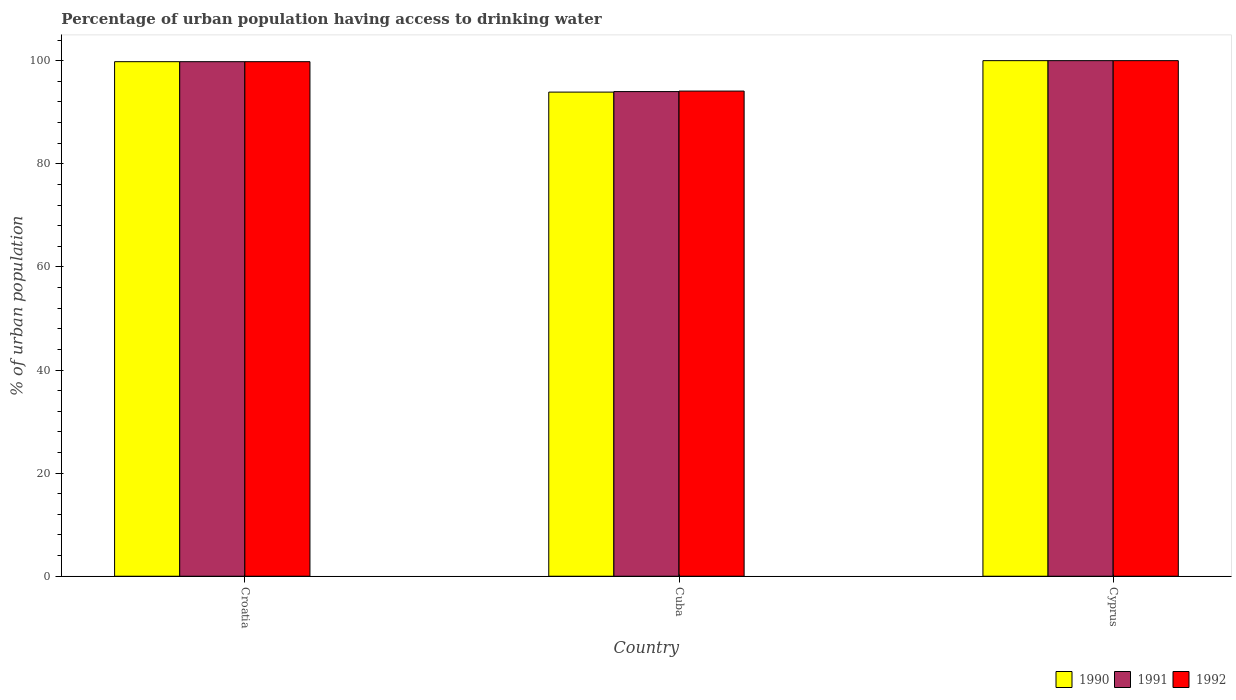How many different coloured bars are there?
Provide a short and direct response. 3. How many groups of bars are there?
Your answer should be compact. 3. Are the number of bars per tick equal to the number of legend labels?
Give a very brief answer. Yes. What is the label of the 1st group of bars from the left?
Keep it short and to the point. Croatia. What is the percentage of urban population having access to drinking water in 1991 in Cuba?
Offer a very short reply. 94. Across all countries, what is the minimum percentage of urban population having access to drinking water in 1992?
Give a very brief answer. 94.1. In which country was the percentage of urban population having access to drinking water in 1990 maximum?
Offer a very short reply. Cyprus. In which country was the percentage of urban population having access to drinking water in 1992 minimum?
Your answer should be compact. Cuba. What is the total percentage of urban population having access to drinking water in 1991 in the graph?
Your answer should be compact. 293.8. What is the difference between the percentage of urban population having access to drinking water in 1990 in Cuba and that in Cyprus?
Keep it short and to the point. -6.1. What is the difference between the percentage of urban population having access to drinking water in 1992 in Croatia and the percentage of urban population having access to drinking water in 1991 in Cuba?
Your response must be concise. 5.8. What is the average percentage of urban population having access to drinking water in 1990 per country?
Offer a terse response. 97.9. In how many countries, is the percentage of urban population having access to drinking water in 1991 greater than 88 %?
Your answer should be compact. 3. What is the ratio of the percentage of urban population having access to drinking water in 1992 in Cuba to that in Cyprus?
Your answer should be compact. 0.94. What is the difference between the highest and the second highest percentage of urban population having access to drinking water in 1991?
Make the answer very short. -0.2. What is the difference between the highest and the lowest percentage of urban population having access to drinking water in 1990?
Your answer should be compact. 6.1. In how many countries, is the percentage of urban population having access to drinking water in 1992 greater than the average percentage of urban population having access to drinking water in 1992 taken over all countries?
Your answer should be very brief. 2. Is the sum of the percentage of urban population having access to drinking water in 1992 in Cuba and Cyprus greater than the maximum percentage of urban population having access to drinking water in 1990 across all countries?
Keep it short and to the point. Yes. What does the 1st bar from the right in Cuba represents?
Your answer should be compact. 1992. Is it the case that in every country, the sum of the percentage of urban population having access to drinking water in 1990 and percentage of urban population having access to drinking water in 1992 is greater than the percentage of urban population having access to drinking water in 1991?
Provide a succinct answer. Yes. How many bars are there?
Your response must be concise. 9. How many countries are there in the graph?
Give a very brief answer. 3. Does the graph contain grids?
Your answer should be very brief. No. What is the title of the graph?
Offer a terse response. Percentage of urban population having access to drinking water. What is the label or title of the Y-axis?
Offer a terse response. % of urban population. What is the % of urban population in 1990 in Croatia?
Give a very brief answer. 99.8. What is the % of urban population in 1991 in Croatia?
Make the answer very short. 99.8. What is the % of urban population in 1992 in Croatia?
Offer a terse response. 99.8. What is the % of urban population in 1990 in Cuba?
Offer a terse response. 93.9. What is the % of urban population of 1991 in Cuba?
Your answer should be compact. 94. What is the % of urban population of 1992 in Cuba?
Provide a succinct answer. 94.1. What is the % of urban population in 1990 in Cyprus?
Keep it short and to the point. 100. What is the % of urban population in 1991 in Cyprus?
Provide a short and direct response. 100. What is the % of urban population in 1992 in Cyprus?
Your answer should be very brief. 100. Across all countries, what is the maximum % of urban population of 1991?
Provide a succinct answer. 100. Across all countries, what is the maximum % of urban population of 1992?
Provide a succinct answer. 100. Across all countries, what is the minimum % of urban population in 1990?
Keep it short and to the point. 93.9. Across all countries, what is the minimum % of urban population in 1991?
Provide a succinct answer. 94. Across all countries, what is the minimum % of urban population in 1992?
Give a very brief answer. 94.1. What is the total % of urban population of 1990 in the graph?
Offer a very short reply. 293.7. What is the total % of urban population of 1991 in the graph?
Your answer should be very brief. 293.8. What is the total % of urban population of 1992 in the graph?
Offer a very short reply. 293.9. What is the difference between the % of urban population of 1990 in Croatia and that in Cuba?
Provide a succinct answer. 5.9. What is the difference between the % of urban population in 1991 in Croatia and that in Cuba?
Provide a succinct answer. 5.8. What is the difference between the % of urban population of 1992 in Croatia and that in Cuba?
Make the answer very short. 5.7. What is the difference between the % of urban population in 1991 in Croatia and that in Cyprus?
Your response must be concise. -0.2. What is the difference between the % of urban population of 1990 in Croatia and the % of urban population of 1992 in Cyprus?
Provide a short and direct response. -0.2. What is the difference between the % of urban population in 1990 in Cuba and the % of urban population in 1992 in Cyprus?
Offer a terse response. -6.1. What is the average % of urban population in 1990 per country?
Your answer should be very brief. 97.9. What is the average % of urban population of 1991 per country?
Ensure brevity in your answer.  97.93. What is the average % of urban population of 1992 per country?
Give a very brief answer. 97.97. What is the difference between the % of urban population in 1990 and % of urban population in 1992 in Croatia?
Offer a very short reply. 0. What is the difference between the % of urban population of 1991 and % of urban population of 1992 in Croatia?
Offer a very short reply. 0. What is the difference between the % of urban population of 1990 and % of urban population of 1991 in Cuba?
Give a very brief answer. -0.1. What is the difference between the % of urban population in 1990 and % of urban population in 1992 in Cyprus?
Ensure brevity in your answer.  0. What is the ratio of the % of urban population in 1990 in Croatia to that in Cuba?
Offer a very short reply. 1.06. What is the ratio of the % of urban population of 1991 in Croatia to that in Cuba?
Provide a short and direct response. 1.06. What is the ratio of the % of urban population of 1992 in Croatia to that in Cuba?
Provide a short and direct response. 1.06. What is the ratio of the % of urban population of 1990 in Croatia to that in Cyprus?
Ensure brevity in your answer.  1. What is the ratio of the % of urban population of 1991 in Croatia to that in Cyprus?
Provide a succinct answer. 1. What is the ratio of the % of urban population in 1990 in Cuba to that in Cyprus?
Ensure brevity in your answer.  0.94. What is the ratio of the % of urban population in 1992 in Cuba to that in Cyprus?
Ensure brevity in your answer.  0.94. What is the difference between the highest and the second highest % of urban population of 1992?
Provide a succinct answer. 0.2. What is the difference between the highest and the lowest % of urban population of 1990?
Give a very brief answer. 6.1. What is the difference between the highest and the lowest % of urban population of 1992?
Make the answer very short. 5.9. 